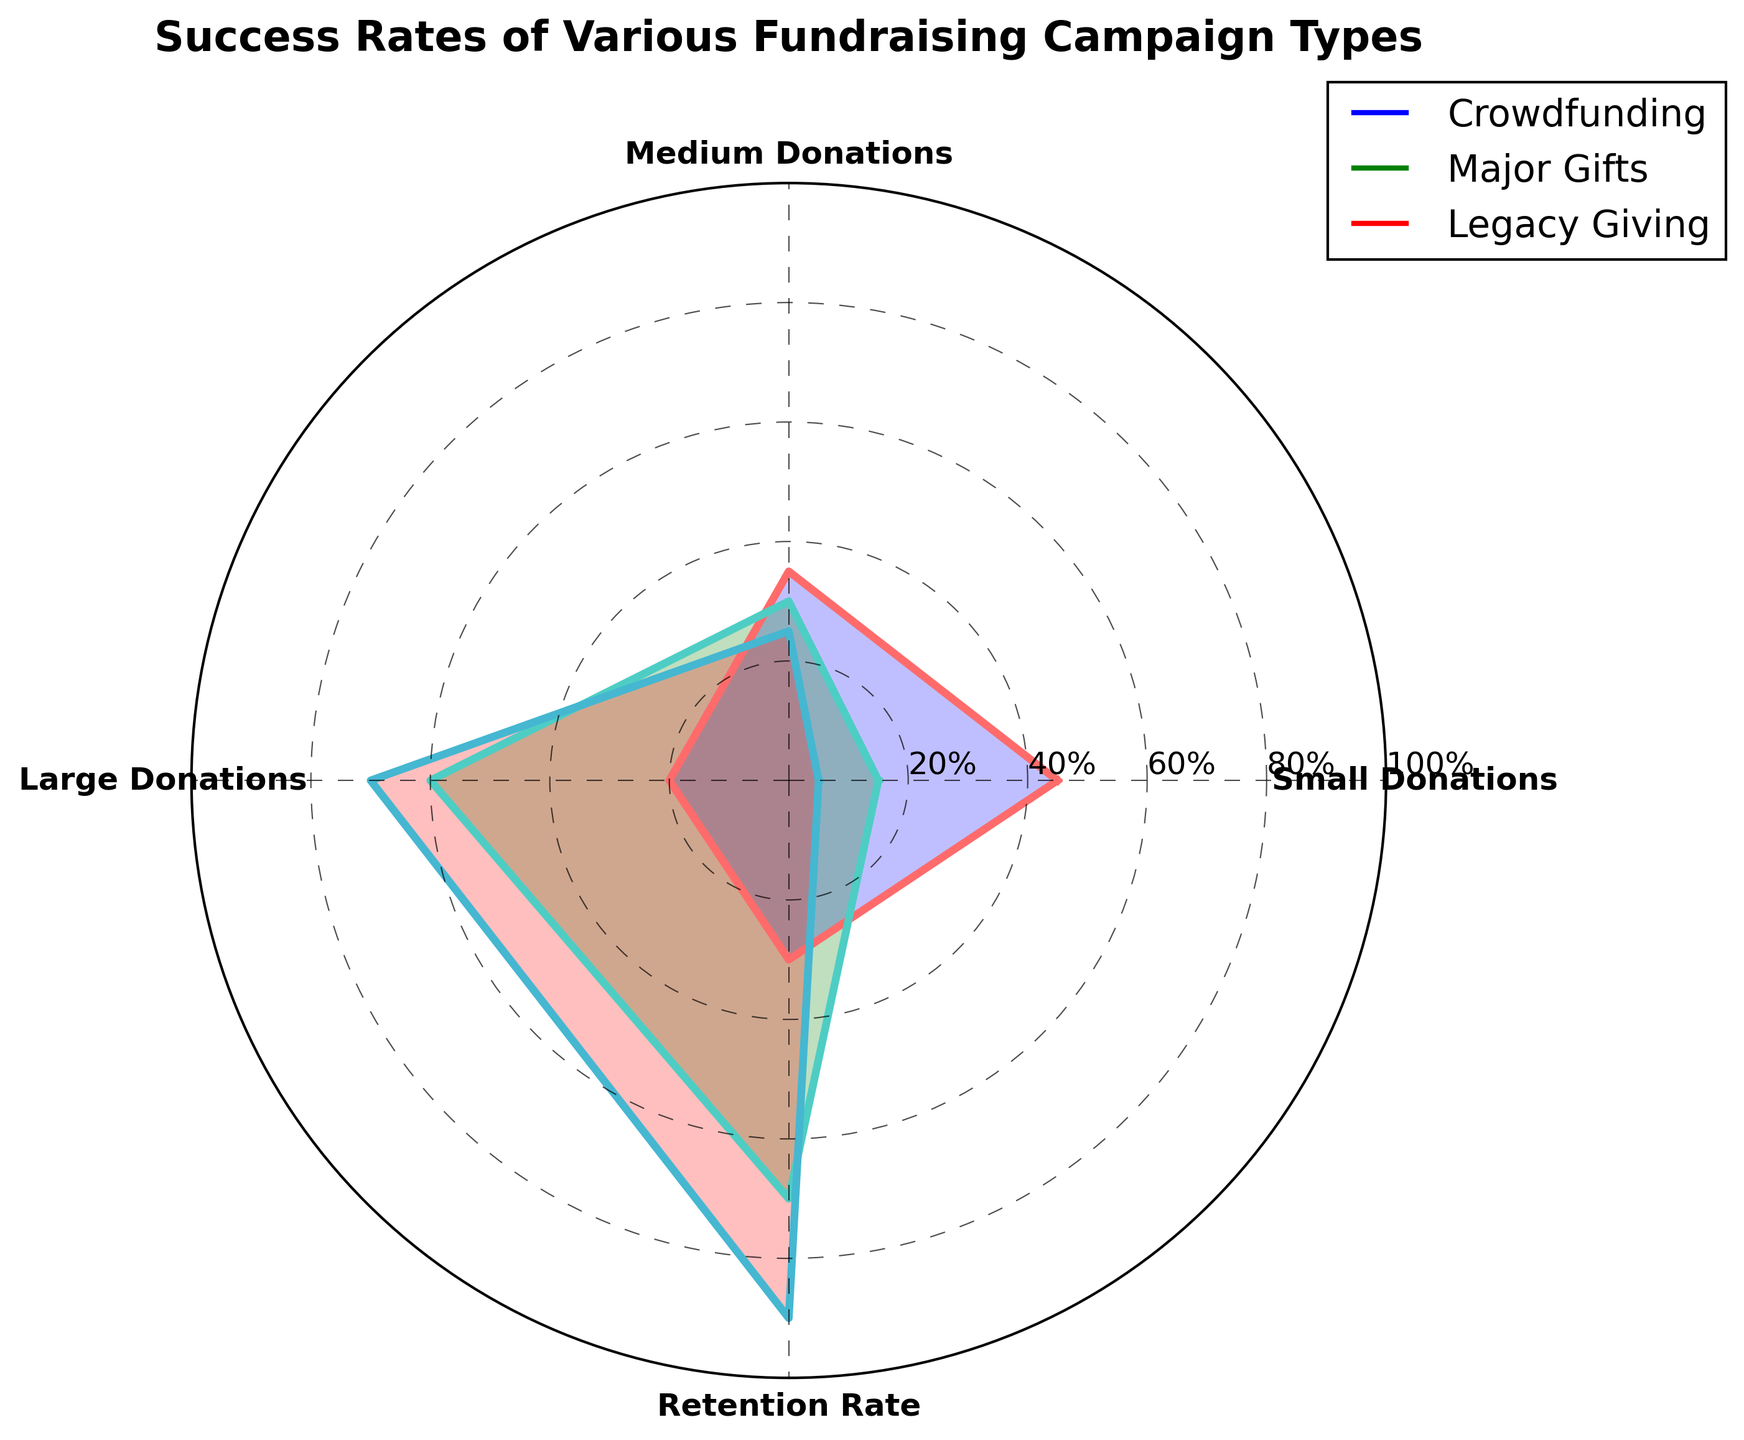What's the title of the figure? The title is centrally placed at the top of the figure, above the radar chart. It provides a summary of what the chart represents.
Answer: Success Rates of Various Fundraising Campaign Types How many campaign types are shown in the radar chart? There are three distinct lines and labels representing the different campaign types in the legend on the right side of the chart.
Answer: 3 Which campaign type has the highest retention rate? By looking at the segment labeled "Retention Rate" and observing the extent of each campaign's line, the line for Legacy Giving reaches the highest point.
Answer: Legacy Giving For which campaign type, are large donations the largest proportion? The segment labeled "Large Donations" shows that Legacy Giving has the line reaching the highest point compared to Crowdfunding and Major Gifts.
Answer: Legacy Giving Which campaign type has the lowest rate of small donations? By examining the "Small Donations" segment, the line for Legacy Giving is the shortest.
Answer: Legacy Giving What is the average rate of Crowdfunding across all categories? The values for Crowdfunding in the categories are: 45, 35, 20, and 30. Sum them up to get 130, then divide by 4 to find the average.
Answer: 32.5 How does the retention rate of Major Gifts compare to Crowdfunding? The retention rate for Major Gifts is at 70, whereas for Crowdfunding it's at 30. Major Gifts has a higher retention rate.
Answer: Major Gifts has a higher retention rate Which campaign type shows the greatest variability in the success rates across the different categories? Variability can be estimated by looking at the differences in the lengths of the lines for each campaign type. The more varied the lengths, the greater the variability. Major Gifts shows high variability, with values like 60 in Large Donations and 15 in Small Donations.
Answer: Major Gifts Which segments show that Major Gifts outperform Crowdfunding? By comparing the lines within each segment, Major Gifts outperforms Crowdfunding in Medium Donations (30 vs 35), Large Donations (60 vs 20), and Retention Rate (70 vs 30).
Answer: Medium Donations, Large Donations, and Retention Rate How much higher is the retention rate for Legacy Giving compared to Major Gifts? The retention rate for Legacy Giving is 90, and for Major Gifts, it is 70. The difference is 90 - 70.
Answer: 20 